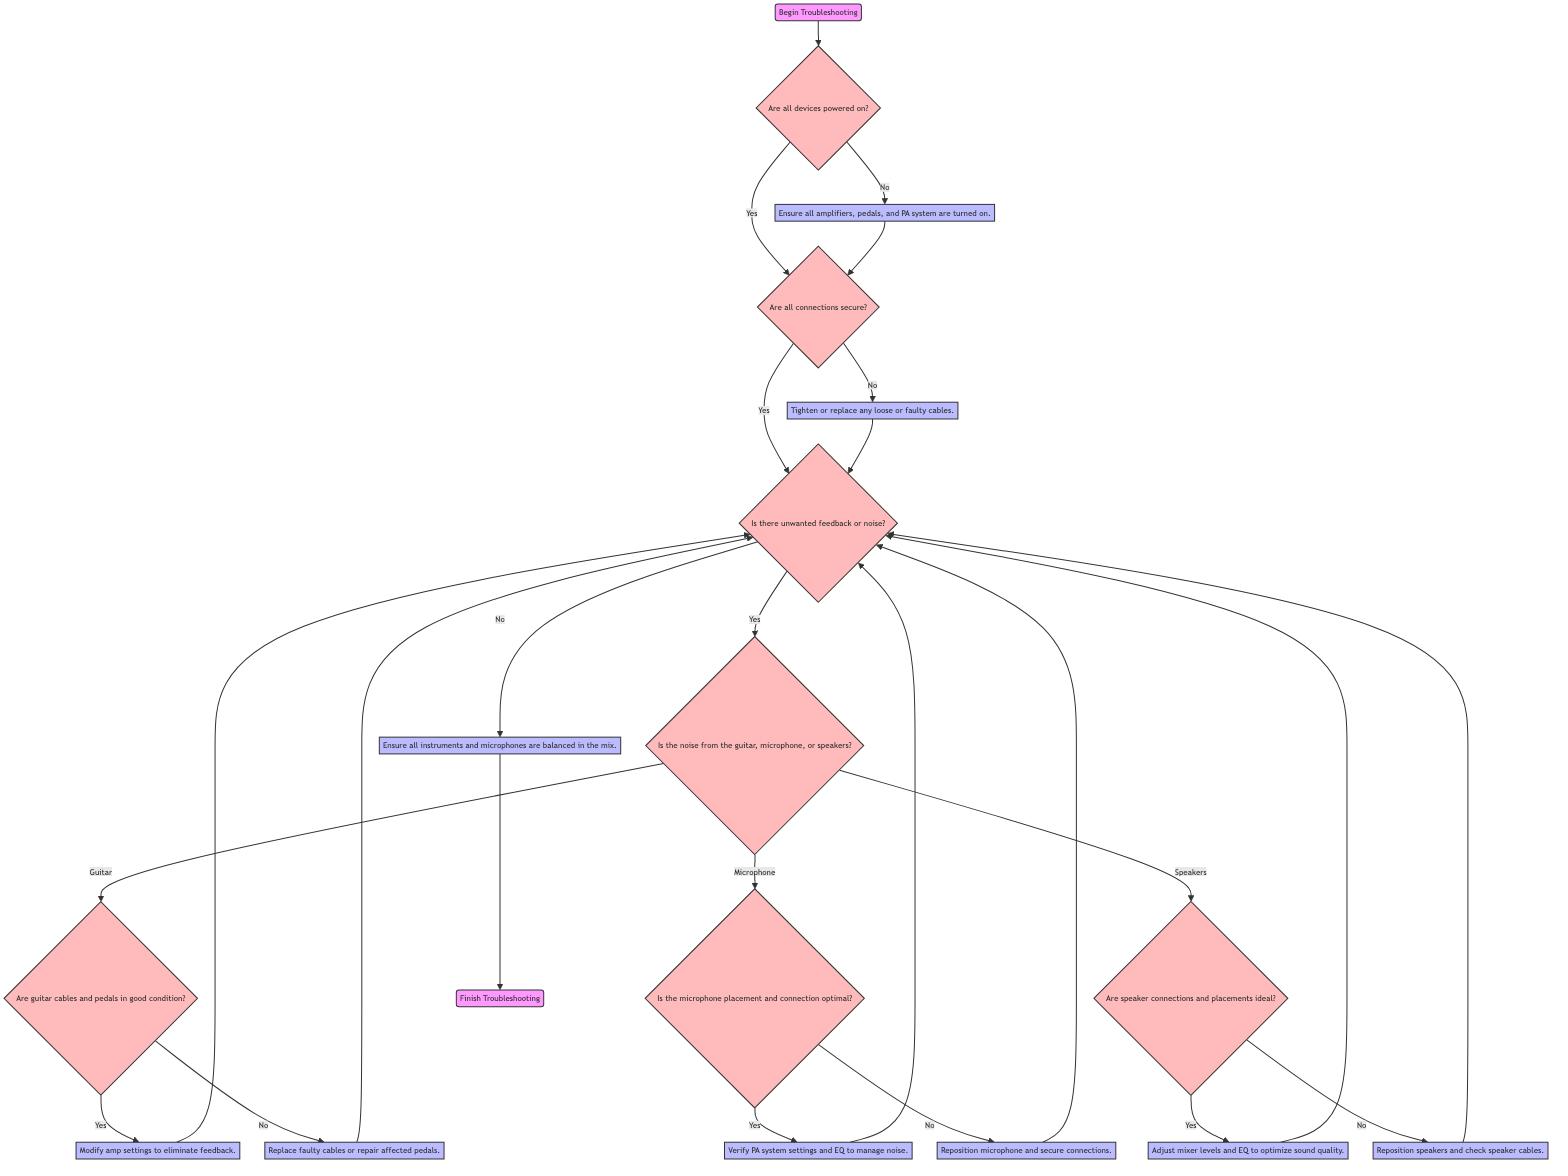What is the first action in the flow chart? The flow chart starts with the node labeled "Begin Troubleshooting". This directs the troubleshooting process from the very beginning.
Answer: Begin Troubleshooting How many questions are in the flow chart? By examining the diagram, we can count a total of 8 question nodes throughout the flow chart. These nodes involve inquiries about device power, connection security, sound quality, noise sources, and other setups.
Answer: 8 What happens if all connections are secure? If all connections are secure, the next step in the diagram is to monitor sound quality, as indicated by the flow from the "CheckConnections" node to the "MonitorSoundQuality" node.
Answer: Monitor sound quality What is the action taken if the guitar cables are not in good condition? If the guitar cables and pedals are not in good condition, the next action taken is to replace or repair the guitar equipment, which is specified in the diagram after the "CheckGuitarSetup" question node.
Answer: Replace or repair guitar equipment What does the flow diagram show after identifying noise source as coming from the microphone? If the noise source is identified as coming from the microphone, the flow diagram shows to check the microphone setup next, as represented by the connecting arrow leading to the "CheckMicrophoneSetup" node.
Answer: Check microphone setup What happens after adjusting microphone setup? Following the action of adjusting the microphone setup, the flow indicates that the next step is to monitor sound quality, reflecting that adjustments in setup lead back to assessing the overall sound.
Answer: Monitor sound quality What is the final step in the troubleshooting process? The last node in the flow chart is labeled "Finish Troubleshooting", indicating completion of the troubleshooting process once all steps have been executed and resolved.
Answer: Finish Troubleshooting What action is taken after ensuring that all devices are powered on? After confirming that all devices are powered on, the troubleshooting process proceeds to the "CheckConnections" node, where the next step involves verifying the security of connections.
Answer: Check connections What is one reason for adjusting amp settings? The flow chart specifies modifying amp settings as a method to eliminate feedback, which is indicated as a subsequent action after confirming guitar cables are in good condition.
Answer: Eliminate feedback 